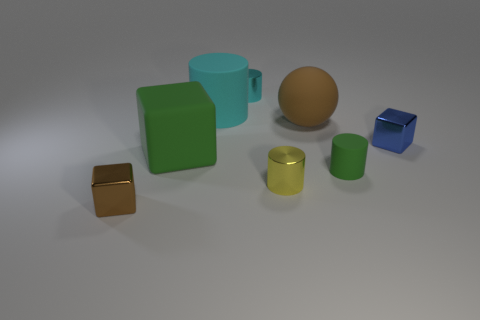Can you describe the lighting condition in this scene? The scene is evenly lit by a soft, diffused light source that creates subtle shadows behind the objects, suggesting an interior setting with ambient lighting. 